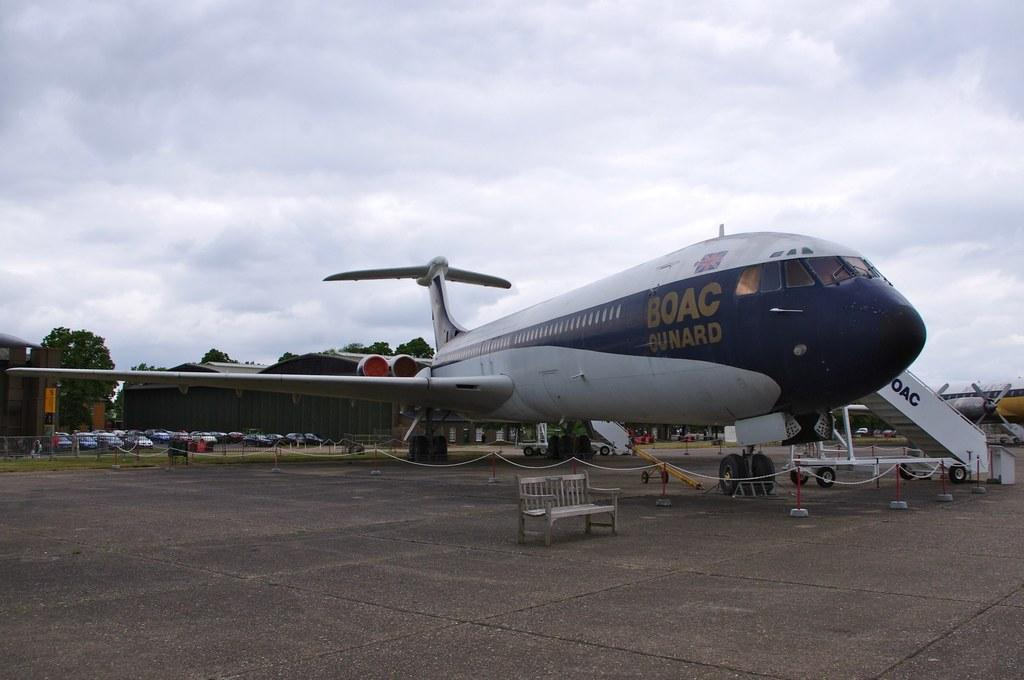What is the main subject of the image? The main subject of the image is an airplane. What can be seen in the background of the image? In the background of the image, there are vehicles, buildings, trees, and a cloudy sky. Can you describe the weather condition in the image? The sky is cloudy in the image, which suggests a partly cloudy or overcast day. What type of straw is being used to stir the river in the image? There is no straw or river present in the image; it features an airplane and a background with vehicles, buildings, trees, and a cloudy sky. 